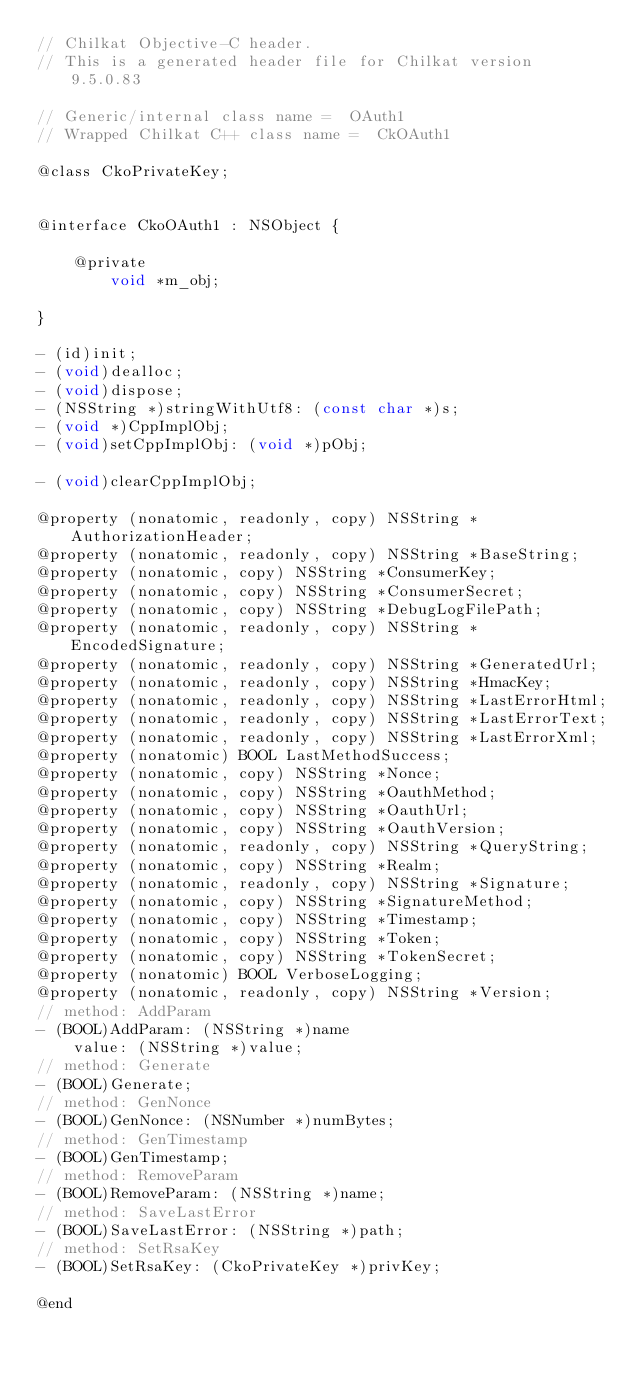Convert code to text. <code><loc_0><loc_0><loc_500><loc_500><_C_>// Chilkat Objective-C header.
// This is a generated header file for Chilkat version 9.5.0.83

// Generic/internal class name =  OAuth1
// Wrapped Chilkat C++ class name =  CkOAuth1

@class CkoPrivateKey;


@interface CkoOAuth1 : NSObject {

	@private
		void *m_obj;

}

- (id)init;
- (void)dealloc;
- (void)dispose;
- (NSString *)stringWithUtf8: (const char *)s;
- (void *)CppImplObj;
- (void)setCppImplObj: (void *)pObj;

- (void)clearCppImplObj;

@property (nonatomic, readonly, copy) NSString *AuthorizationHeader;
@property (nonatomic, readonly, copy) NSString *BaseString;
@property (nonatomic, copy) NSString *ConsumerKey;
@property (nonatomic, copy) NSString *ConsumerSecret;
@property (nonatomic, copy) NSString *DebugLogFilePath;
@property (nonatomic, readonly, copy) NSString *EncodedSignature;
@property (nonatomic, readonly, copy) NSString *GeneratedUrl;
@property (nonatomic, readonly, copy) NSString *HmacKey;
@property (nonatomic, readonly, copy) NSString *LastErrorHtml;
@property (nonatomic, readonly, copy) NSString *LastErrorText;
@property (nonatomic, readonly, copy) NSString *LastErrorXml;
@property (nonatomic) BOOL LastMethodSuccess;
@property (nonatomic, copy) NSString *Nonce;
@property (nonatomic, copy) NSString *OauthMethod;
@property (nonatomic, copy) NSString *OauthUrl;
@property (nonatomic, copy) NSString *OauthVersion;
@property (nonatomic, readonly, copy) NSString *QueryString;
@property (nonatomic, copy) NSString *Realm;
@property (nonatomic, readonly, copy) NSString *Signature;
@property (nonatomic, copy) NSString *SignatureMethod;
@property (nonatomic, copy) NSString *Timestamp;
@property (nonatomic, copy) NSString *Token;
@property (nonatomic, copy) NSString *TokenSecret;
@property (nonatomic) BOOL VerboseLogging;
@property (nonatomic, readonly, copy) NSString *Version;
// method: AddParam
- (BOOL)AddParam: (NSString *)name 
	value: (NSString *)value;
// method: Generate
- (BOOL)Generate;
// method: GenNonce
- (BOOL)GenNonce: (NSNumber *)numBytes;
// method: GenTimestamp
- (BOOL)GenTimestamp;
// method: RemoveParam
- (BOOL)RemoveParam: (NSString *)name;
// method: SaveLastError
- (BOOL)SaveLastError: (NSString *)path;
// method: SetRsaKey
- (BOOL)SetRsaKey: (CkoPrivateKey *)privKey;

@end
</code> 